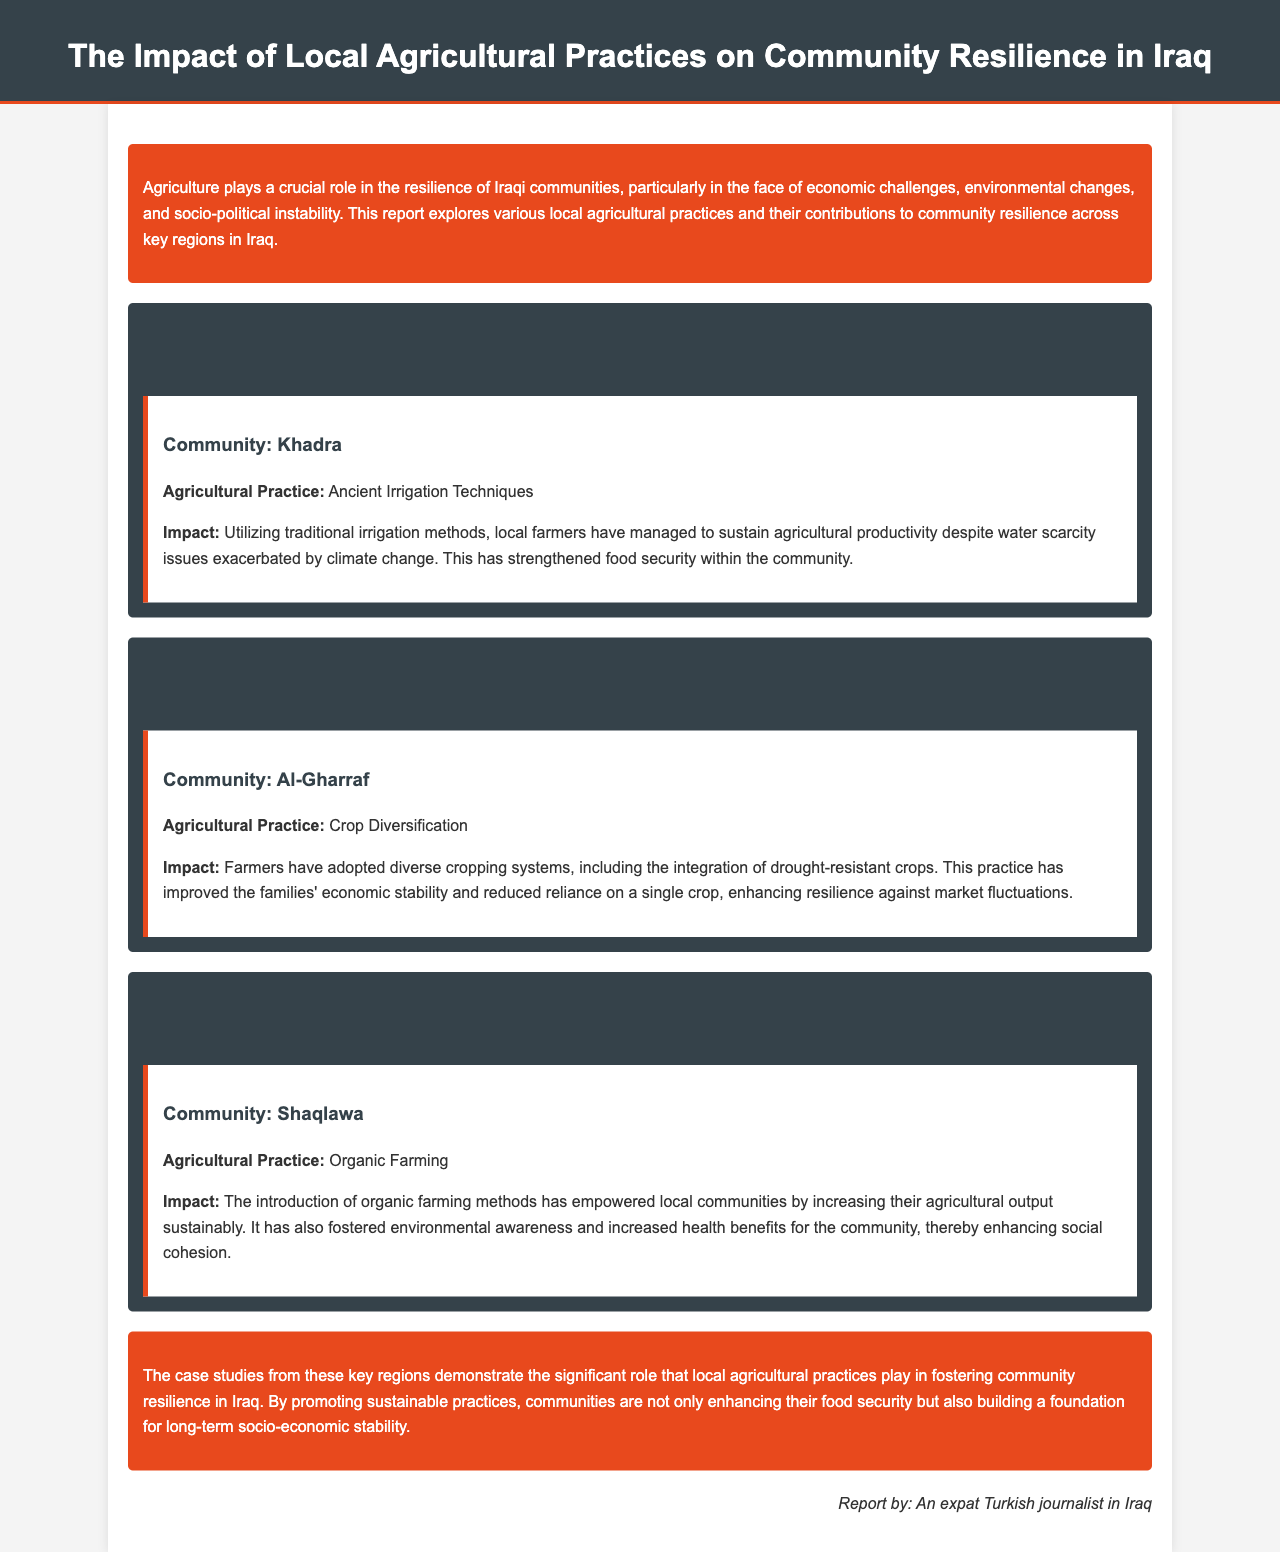What is the title of the report? The title is stated at the beginning of the document.
Answer: The Impact of Local Agricultural Practices on Community Resilience in Iraq Which governorate is associated with ancient irrigation techniques? The document lists agricultural practices linked to specific regions, revealing the associated governorate.
Answer: Nineveh Governorate What agricultural practice is used in Al-Gharraf community? The document details the agricultural practice utilized by the community.
Answer: Crop Diversification What impact did organic farming have on Shaqlawa? The document highlights the effects of organic farming on local communities, providing specific benefits.
Answer: Increased agricultural output sustainably Which region mentions drought-resistant crops? The document cites various practices in different regions, indicating where drought-resistant crops are implemented.
Answer: Dhi Qar Governorate How does traditional irrigation method contribute to community resilience? The document explains the relationship between agricultural practices and community stability, specifically in Nineveh.
Answer: Strengthened food security What is one benefit of organic farming mentioned in the report? The report lists multiple benefits of sustainable practices, focusing particularly on health and awareness.
Answer: Increased health benefits How has crop diversification affected economic stability? The document provides insight into how diverse cropping systems influence community economics.
Answer: Improved families' economic stability 